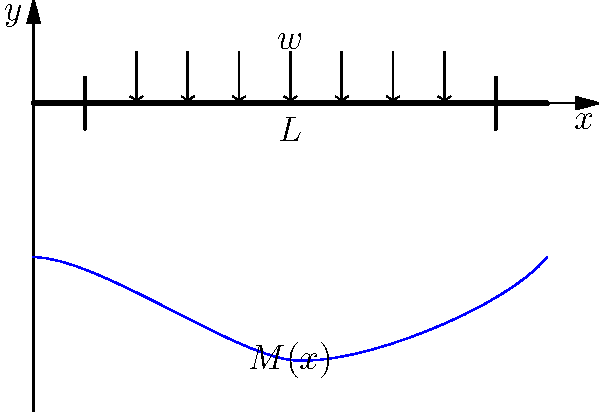Consider a simply supported beam of length $L$ subjected to a uniformly distributed load $w$ as shown in the figure. In the context of ethical patient care and autonomy, how does understanding the bending moment distribution $M(x)$ along the beam relate to assessing and managing stress in healthcare professionals? To answer this question, we need to consider both the mechanical engineering principles and their analogy to healthcare:

1. Bending moment distribution:
   The bending moment $M(x)$ for a simply supported beam under uniformly distributed load is given by:
   $$M(x) = \frac{wx}{2}(L-x)$$

2. Maximum bending moment:
   The maximum bending moment occurs at the center of the beam $(x=L/2)$:
   $$M_{max} = \frac{wL^2}{8}$$

3. Stress-moment relationship:
   The maximum stress in the beam is directly proportional to the bending moment:
   $$\sigma_{max} = \frac{M_{max}y}{I}$$
   where $y$ is the distance from the neutral axis, and $I$ is the moment of inertia.

4. Healthcare analogy:
   a. The beam represents a healthcare professional's capacity to handle stress.
   b. The distributed load represents the various stressors in healthcare.
   c. The bending moment distribution represents the varying levels of stress experienced.
   d. The maximum stress point represents the peak stress level a healthcare professional might experience.

5. Ethical considerations:
   a. Understanding stress distribution helps in identifying high-stress areas in healthcare.
   b. This knowledge can be used to implement targeted interventions and support systems.
   c. Promoting autonomy by allowing healthcare professionals to recognize and manage their stress levels.

6. Patient care implications:
   a. Reduced stress in healthcare professionals leads to better patient care.
   b. Ethical practice is enhanced when professionals are operating under manageable stress levels.
   c. Patient autonomy is better respected when healthcare providers are not overly stressed.

Understanding the bending moment distribution in a beam is analogous to recognizing stress patterns in healthcare professionals. This knowledge allows for the development of strategies to manage and distribute stress more effectively, ultimately leading to improved patient care and ethical practice.
Answer: Understanding stress distribution in beams helps identify and manage stress patterns in healthcare professionals, leading to improved patient care and ethical practice. 